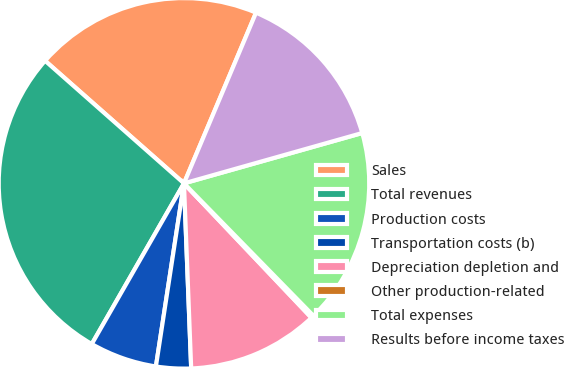Convert chart to OTSL. <chart><loc_0><loc_0><loc_500><loc_500><pie_chart><fcel>Sales<fcel>Total revenues<fcel>Production costs<fcel>Transportation costs (b)<fcel>Depreciation depletion and<fcel>Other production-related<fcel>Total expenses<fcel>Results before income taxes<nl><fcel>19.85%<fcel>28.22%<fcel>5.87%<fcel>3.04%<fcel>11.46%<fcel>0.24%<fcel>17.06%<fcel>14.26%<nl></chart> 